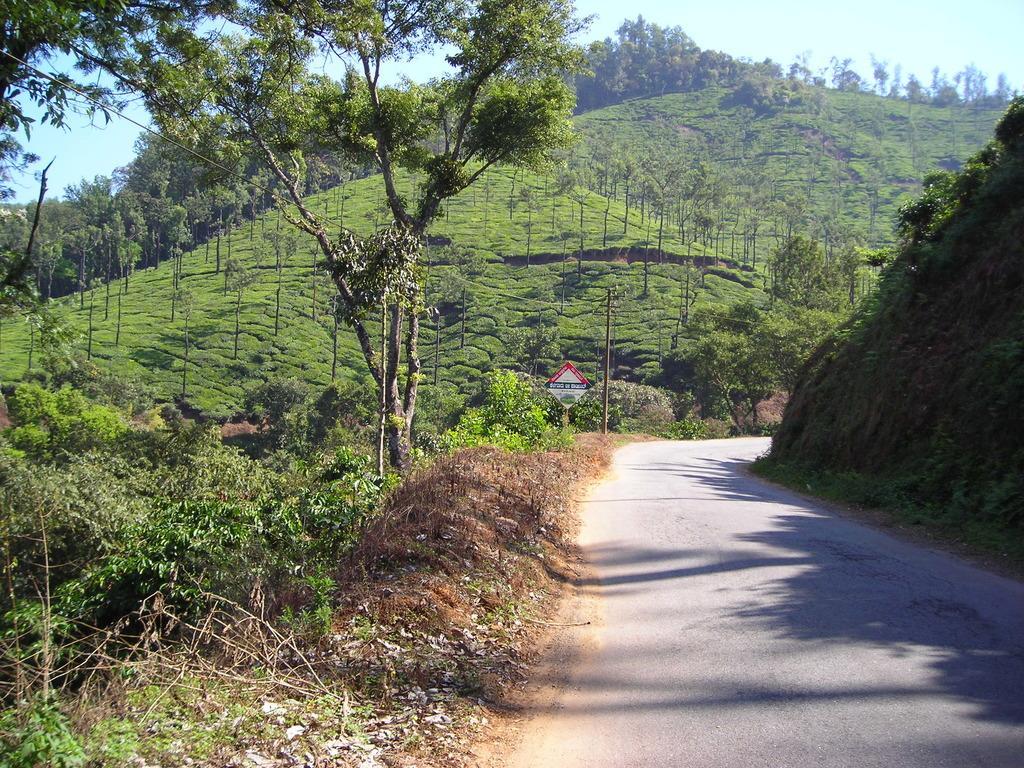Please provide a concise description of this image. In this image at the bottom there is walkway, and some sand grass and some plants. And in the background there are mountains, poles, boards, trees and grass. At the top there is sky. 